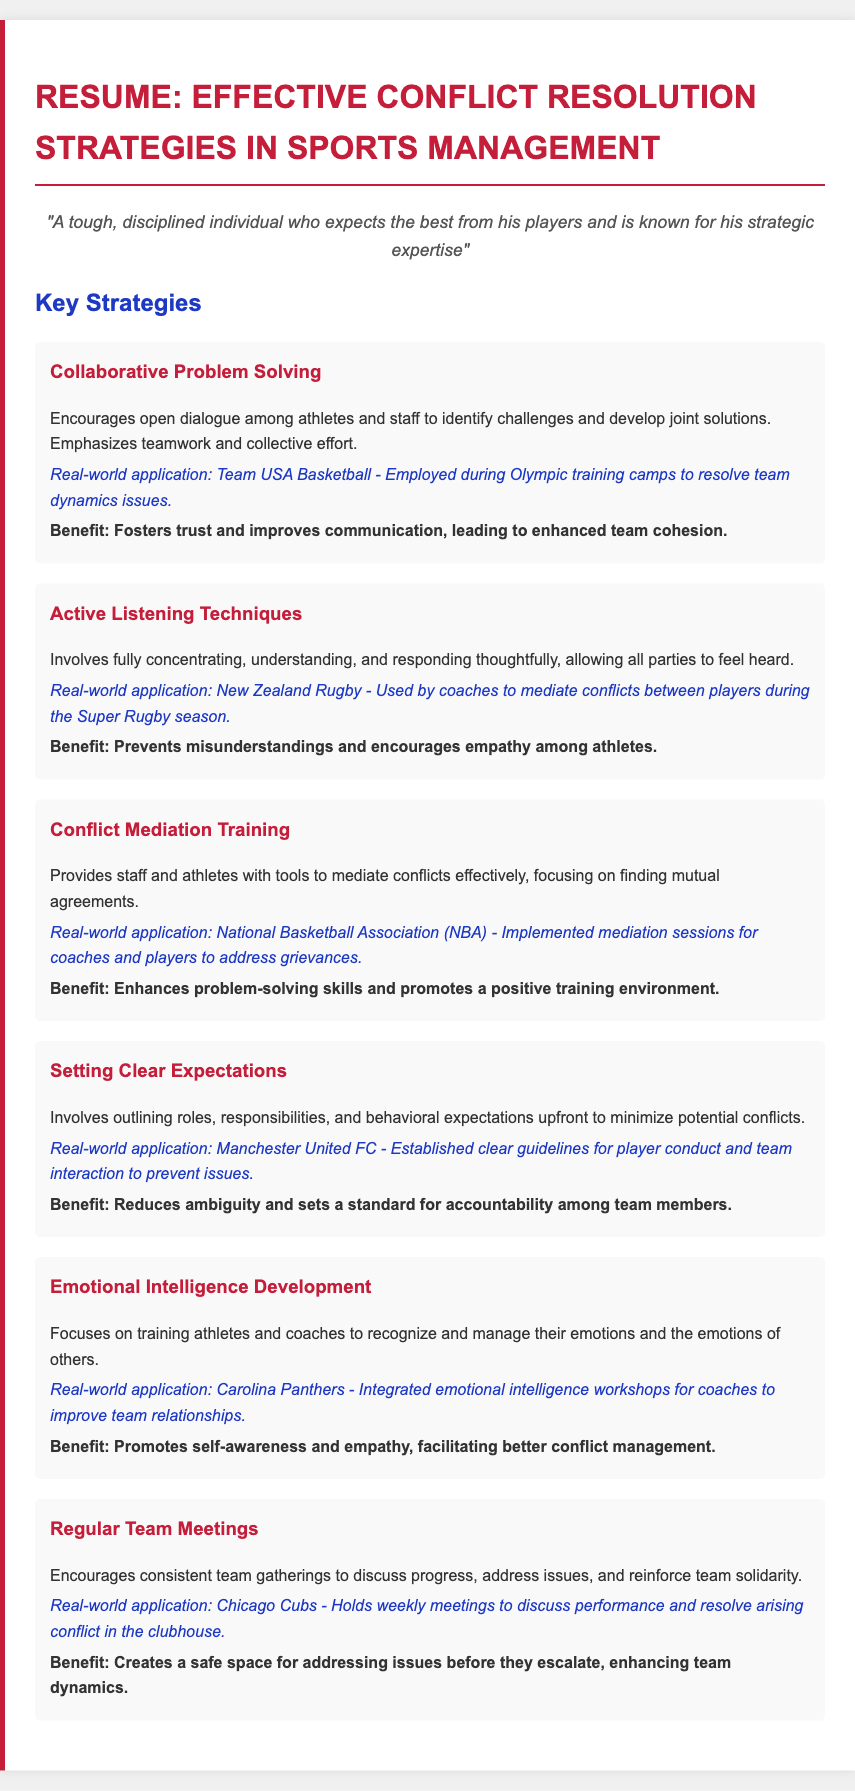What is the first strategy listed in the resume? The first strategy in the resume is Collaborative Problem Solving.
Answer: Collaborative Problem Solving Which organization employed the Active Listening Techniques? The organization that used Active Listening Techniques is New Zealand Rugby.
Answer: New Zealand Rugby What benefit does Setting Clear Expectations provide? The benefit of Setting Clear Expectations is that it reduces ambiguity and sets a standard for accountability among team members.
Answer: Reduces ambiguity and sets a standard for accountability among team members How many key strategies are detailed in the resume? The resume outlines six key strategies.
Answer: Six Which football club established clear guidelines for player conduct? The football club that established clear guidelines is Manchester United FC.
Answer: Manchester United FC What is the purpose of Regular Team Meetings in conflict resolution? The purpose of Regular Team Meetings is to create a safe space for addressing issues before they escalate.
Answer: Create a safe space for addressing issues before they escalate What type of training did the Carolina Panthers integrate for coaches? The Carolina Panthers integrated emotional intelligence workshops for coaches.
Answer: Emotional intelligence workshops What approach does Conflict Mediation Training focus on? Conflict Mediation Training focuses on finding mutual agreements.
Answer: Finding mutual agreements 